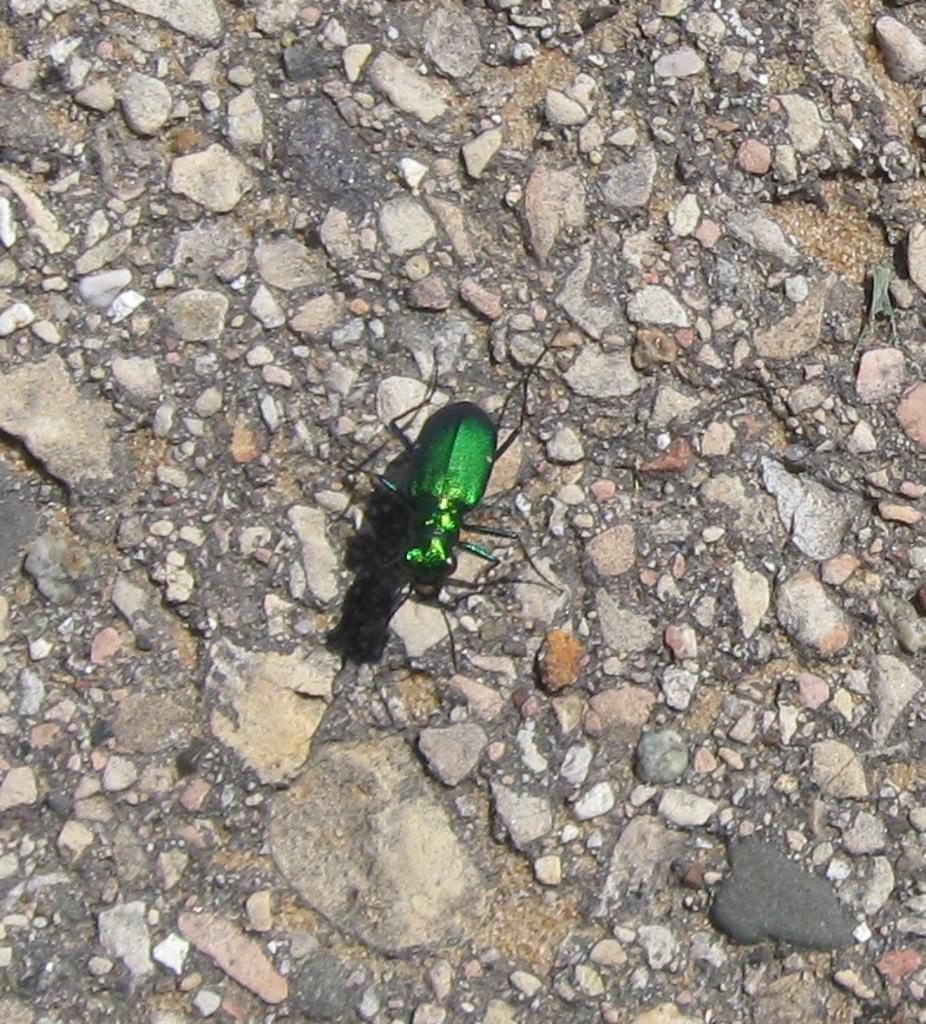In one or two sentences, can you explain what this image depicts? There is one insect present on the ground as we can see in the middle of this image. We can see the small stones present in the ground. 